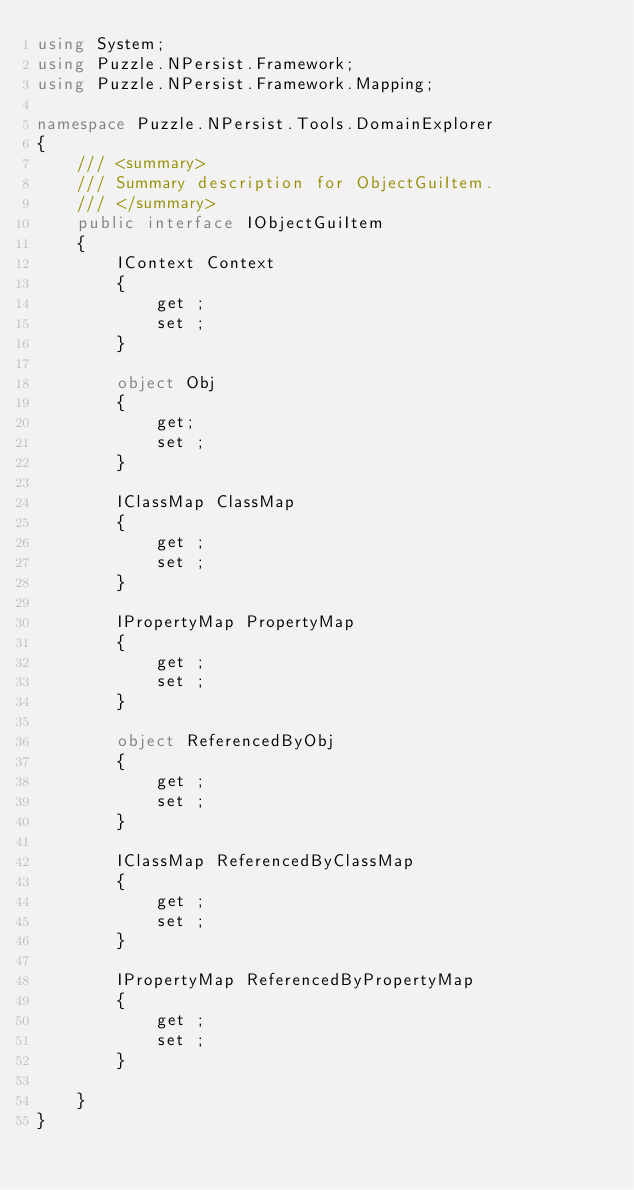Convert code to text. <code><loc_0><loc_0><loc_500><loc_500><_C#_>using System;
using Puzzle.NPersist.Framework;
using Puzzle.NPersist.Framework.Mapping;

namespace Puzzle.NPersist.Tools.DomainExplorer
{
	/// <summary>
	/// Summary description for ObjectGuiItem.
	/// </summary>
	public interface IObjectGuiItem
	{
		IContext Context
		{
			get ;
			set ;
		}
		
		object Obj
		{
			get;
			set ;
		}
		
		IClassMap ClassMap
		{
			get ;
			set ;
		}
		
		IPropertyMap PropertyMap
		{
			get ;
			set ;
		}

		object ReferencedByObj
		{
			get ;
			set ;
		}
		
		IClassMap ReferencedByClassMap
		{
			get ;
			set ;
		}
		
		IPropertyMap ReferencedByPropertyMap
		{
			get ;
			set ;
		}
		
	}
}
</code> 